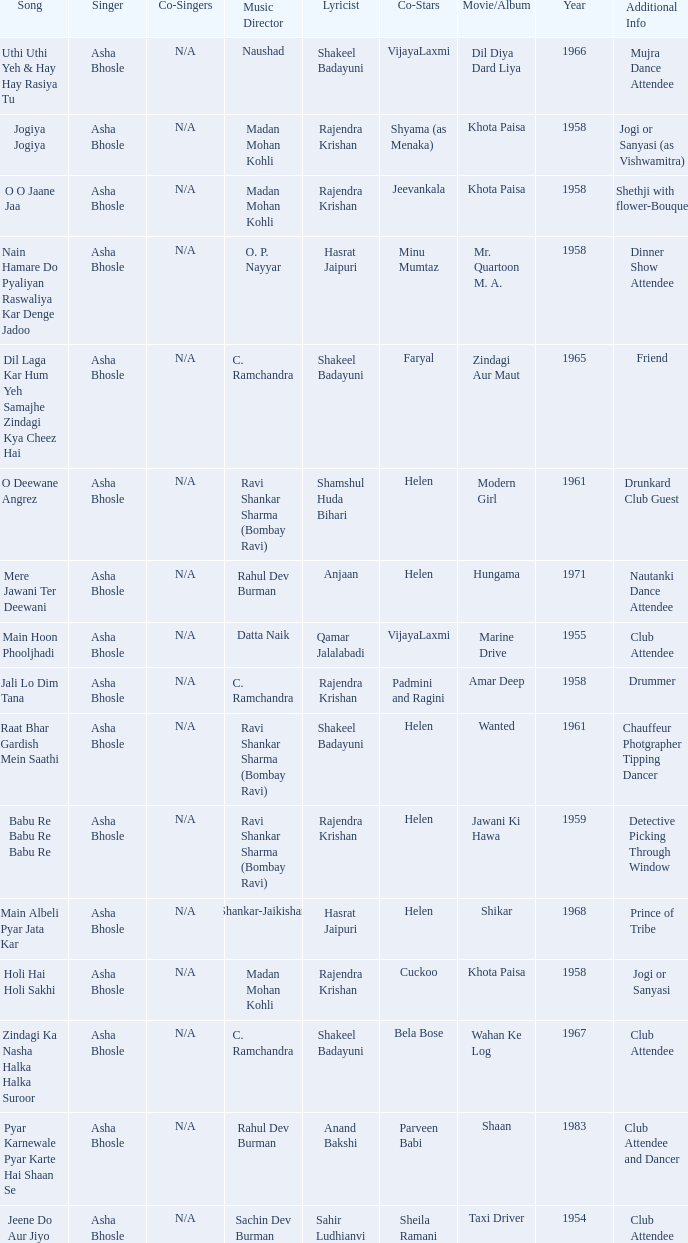Who wrote the lyrics when Jeevankala co-starred? Rajendra Krishan. 